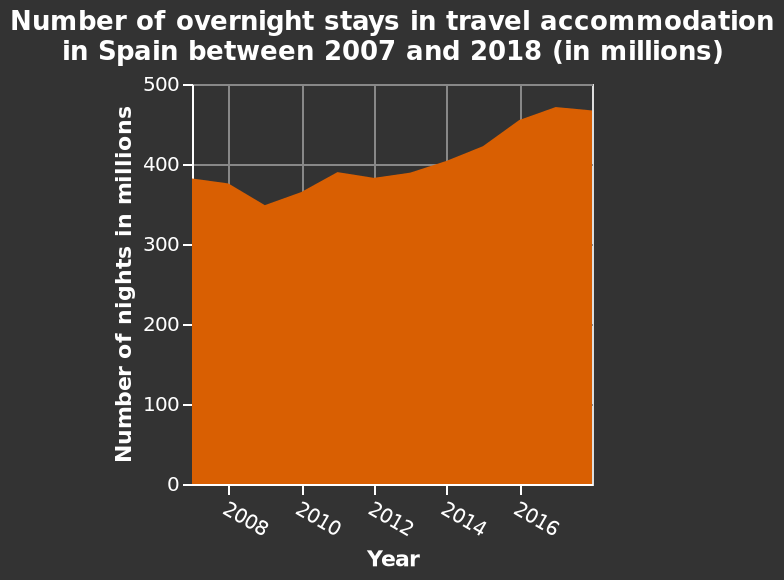<image>
Was there a decrease in the number of stays during a specific period? Yes, there was a dip in stays between 2008-2010. How would you characterize the overall trend in overnight stays? The overall trend in overnight stays is upward, with some fluctuations during certain periods. What is the unit of measurement for the y-axis? The y-axis is marked in "Number of nights in millions." What does the area plot represent? The area plot represents the number of overnight stays in travel accommodation in Spain between 2007 and 2018, measured in millions. 